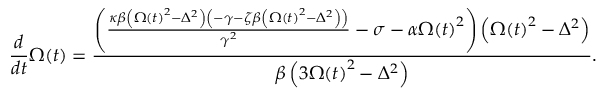<formula> <loc_0><loc_0><loc_500><loc_500>\frac { d } { d t } \Omega \, \left ( t \right ) = \frac { \left ( \frac { \kappa \beta \left ( \Omega \left ( t \right ) ^ { 2 } - \Delta ^ { 2 } \right ) \left ( - \gamma - \zeta \beta \left ( \Omega \left ( t \right ) ^ { 2 } - \Delta ^ { 2 } \right ) \right ) } { \gamma ^ { 2 } } - \sigma - \alpha \Omega \, \left ( t \right ) ^ { 2 } \right ) \left ( \Omega \, \left ( t \right ) ^ { 2 } - \Delta ^ { 2 } \right ) } { \beta \left ( 3 \Omega \, \left ( t \right ) ^ { 2 } - \Delta ^ { 2 } \right ) } .</formula> 